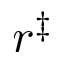Convert formula to latex. <formula><loc_0><loc_0><loc_500><loc_500>r ^ { \ddag }</formula> 